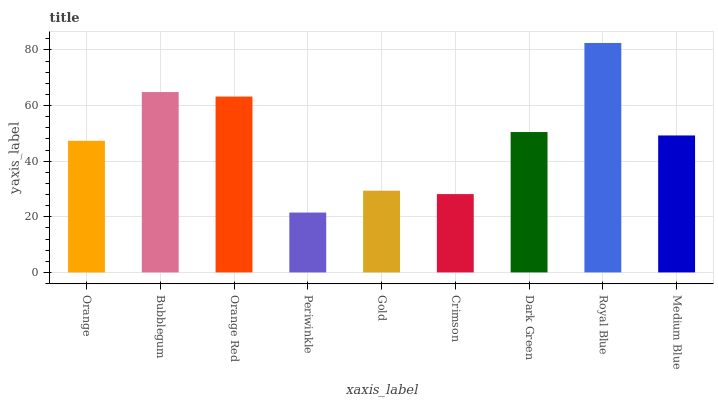Is Bubblegum the minimum?
Answer yes or no. No. Is Bubblegum the maximum?
Answer yes or no. No. Is Bubblegum greater than Orange?
Answer yes or no. Yes. Is Orange less than Bubblegum?
Answer yes or no. Yes. Is Orange greater than Bubblegum?
Answer yes or no. No. Is Bubblegum less than Orange?
Answer yes or no. No. Is Medium Blue the high median?
Answer yes or no. Yes. Is Medium Blue the low median?
Answer yes or no. Yes. Is Bubblegum the high median?
Answer yes or no. No. Is Crimson the low median?
Answer yes or no. No. 